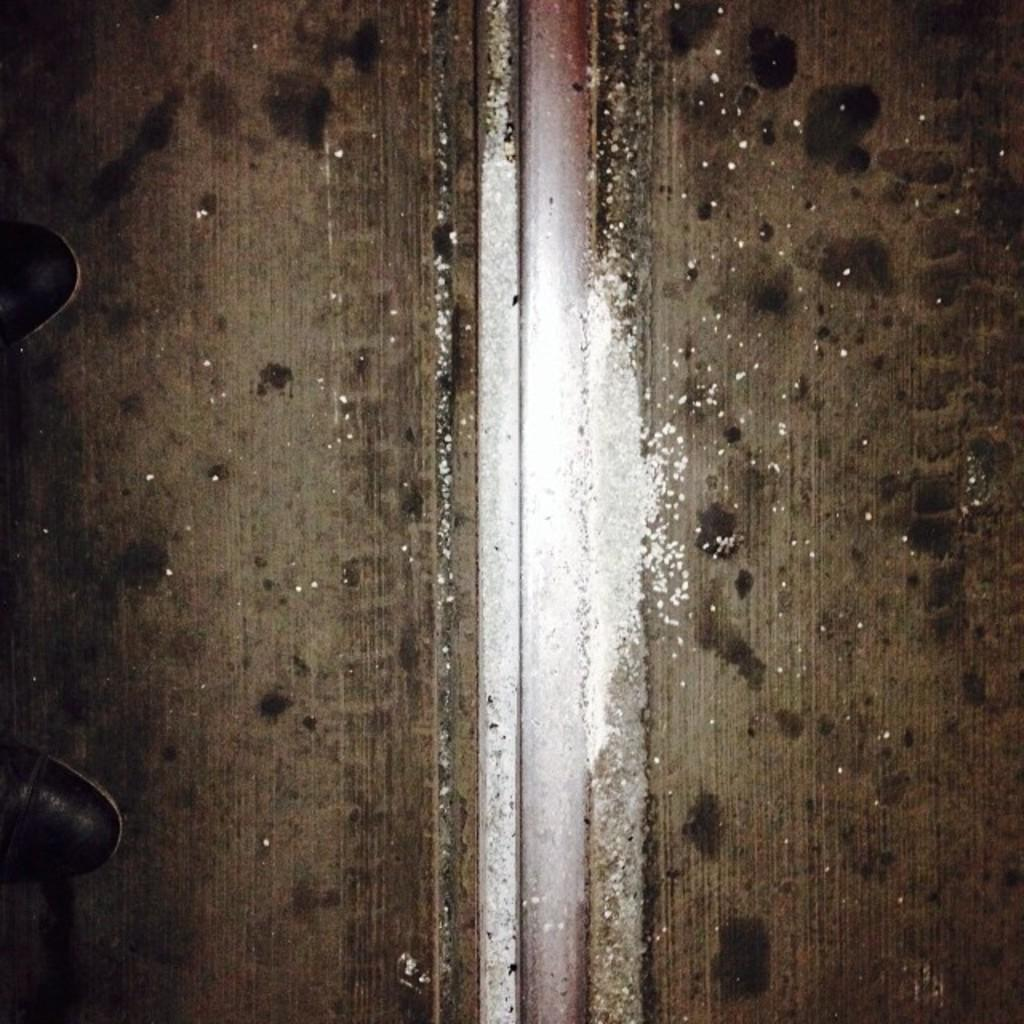What is located on the left side of the image? There are two legs on the left side of the image. What type of setting is depicted in the image? There is a wooded way in the image. What type of meal is being prepared in the image? There is no meal preparation visible in the image; it only shows two legs and a wooded way. Is there an umbrella present in the image? There is no mention of an umbrella in the provided facts, and therefore we cannot confirm its presence in the image. 